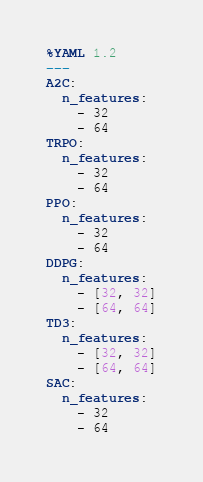Convert code to text. <code><loc_0><loc_0><loc_500><loc_500><_YAML_>%YAML 1.2
---
A2C:
  n_features:
    - 32
    - 64
TRPO:
  n_features:
    - 32
    - 64
PPO:
  n_features:
    - 32
    - 64
DDPG:
  n_features:
    - [32, 32]
    - [64, 64]
TD3:
  n_features:
    - [32, 32]
    - [64, 64]
SAC:
  n_features:
    - 32
    - 64
</code> 